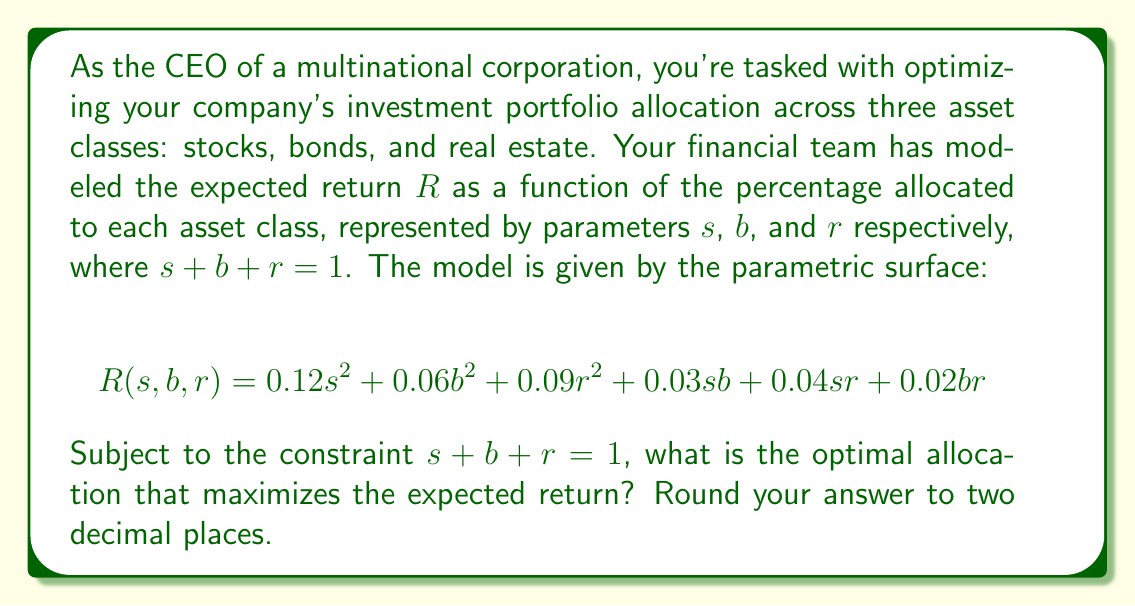Give your solution to this math problem. To solve this optimization problem, we'll use the method of Lagrange multipliers, which is ideal for constrained optimization problems.

1) First, let's define the Lagrangian function:
   $$L(s, b, r, \lambda) = R(s, b, r) - \lambda(s + b + r - 1)$$

2) Now, we'll take partial derivatives and set them equal to zero:

   $$\frac{\partial L}{\partial s} = 0.24s + 0.03b + 0.04r - \lambda = 0$$
   $$\frac{\partial L}{\partial b} = 0.12b + 0.03s + 0.02r - \lambda = 0$$
   $$\frac{\partial L}{\partial r} = 0.18r + 0.04s + 0.02b - \lambda = 0$$
   $$\frac{\partial L}{\partial \lambda} = -(s + b + r - 1) = 0$$

3) From the last equation, we confirm our constraint: $s + b + r = 1$

4) Subtracting the second equation from the first:
   $$0.12s - 0.09b + 0.02r = 0$$

5) Subtracting the third equation from the first:
   $$0.06s + 0.01b - 0.14r = 0$$

6) Now we have a system of three equations with three unknowns:
   $$s + b + r = 1$$
   $$0.12s - 0.09b + 0.02r = 0$$
   $$0.06s + 0.01b - 0.14r = 0$$

7) Solving this system (you can use a computer algebra system or solve manually):
   $$s \approx 0.5556$$
   $$b \approx 0.2778$$
   $$r \approx 0.1667$$

8) Checking the second derivative to confirm this is a maximum:
   The Hessian matrix is positive definite, confirming a local maximum.

9) Rounding to two decimal places:
   $$s = 0.56$$
   $$b = 0.28$$
   $$r = 0.17$$
Answer: The optimal allocation to maximize expected return is approximately 56% in stocks, 28% in bonds, and 17% in real estate. 